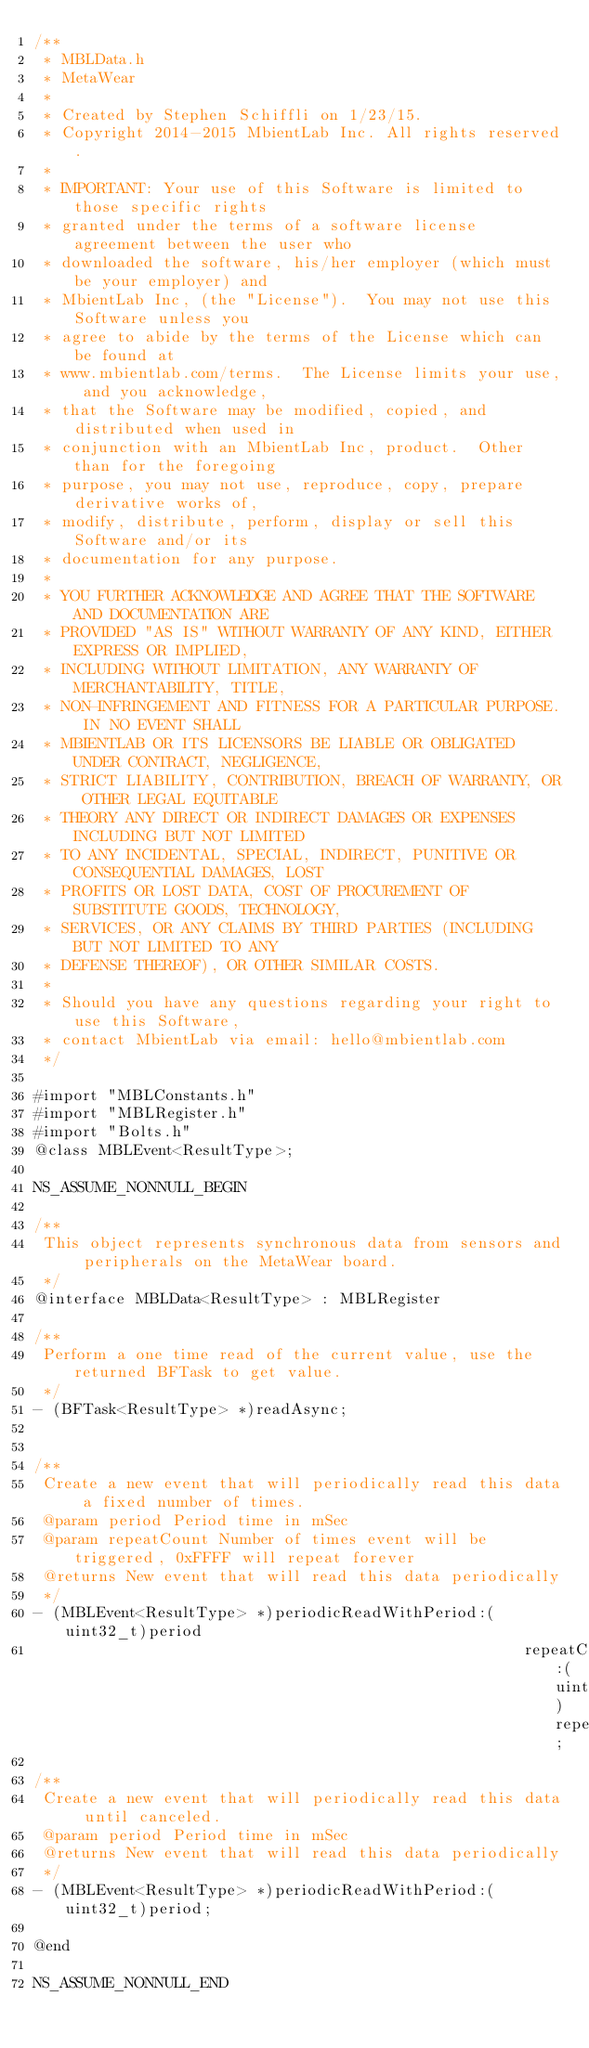Convert code to text. <code><loc_0><loc_0><loc_500><loc_500><_C_>/**
 * MBLData.h
 * MetaWear
 *
 * Created by Stephen Schiffli on 1/23/15.
 * Copyright 2014-2015 MbientLab Inc. All rights reserved.
 *
 * IMPORTANT: Your use of this Software is limited to those specific rights
 * granted under the terms of a software license agreement between the user who
 * downloaded the software, his/her employer (which must be your employer) and
 * MbientLab Inc, (the "License").  You may not use this Software unless you
 * agree to abide by the terms of the License which can be found at
 * www.mbientlab.com/terms.  The License limits your use, and you acknowledge,
 * that the Software may be modified, copied, and distributed when used in
 * conjunction with an MbientLab Inc, product.  Other than for the foregoing
 * purpose, you may not use, reproduce, copy, prepare derivative works of,
 * modify, distribute, perform, display or sell this Software and/or its
 * documentation for any purpose.
 *
 * YOU FURTHER ACKNOWLEDGE AND AGREE THAT THE SOFTWARE AND DOCUMENTATION ARE
 * PROVIDED "AS IS" WITHOUT WARRANTY OF ANY KIND, EITHER EXPRESS OR IMPLIED,
 * INCLUDING WITHOUT LIMITATION, ANY WARRANTY OF MERCHANTABILITY, TITLE,
 * NON-INFRINGEMENT AND FITNESS FOR A PARTICULAR PURPOSE. IN NO EVENT SHALL
 * MBIENTLAB OR ITS LICENSORS BE LIABLE OR OBLIGATED UNDER CONTRACT, NEGLIGENCE,
 * STRICT LIABILITY, CONTRIBUTION, BREACH OF WARRANTY, OR OTHER LEGAL EQUITABLE
 * THEORY ANY DIRECT OR INDIRECT DAMAGES OR EXPENSES INCLUDING BUT NOT LIMITED
 * TO ANY INCIDENTAL, SPECIAL, INDIRECT, PUNITIVE OR CONSEQUENTIAL DAMAGES, LOST
 * PROFITS OR LOST DATA, COST OF PROCUREMENT OF SUBSTITUTE GOODS, TECHNOLOGY,
 * SERVICES, OR ANY CLAIMS BY THIRD PARTIES (INCLUDING BUT NOT LIMITED TO ANY
 * DEFENSE THEREOF), OR OTHER SIMILAR COSTS.
 *
 * Should you have any questions regarding your right to use this Software,
 * contact MbientLab via email: hello@mbientlab.com
 */

#import "MBLConstants.h"
#import "MBLRegister.h"
#import "Bolts.h"
@class MBLEvent<ResultType>;

NS_ASSUME_NONNULL_BEGIN

/**
 This object represents synchronous data from sensors and peripherals on the MetaWear board.
 */
@interface MBLData<ResultType> : MBLRegister

/**
 Perform a one time read of the current value, use the returned BFTask to get value.
 */
- (BFTask<ResultType> *)readAsync;


/**
 Create a new event that will periodically read this data a fixed number of times.
 @param period Period time in mSec
 @param repeatCount Number of times event will be triggered, 0xFFFF will repeat forever
 @returns New event that will read this data periodically
 */
- (MBLEvent<ResultType> *)periodicReadWithPeriod:(uint32_t)period
                                                     repeatCount:(uint16_t)repeatCount;

/**
 Create a new event that will periodically read this data until canceled.
 @param period Period time in mSec
 @returns New event that will read this data periodically
 */
- (MBLEvent<ResultType> *)periodicReadWithPeriod:(uint32_t)period;

@end

NS_ASSUME_NONNULL_END
</code> 